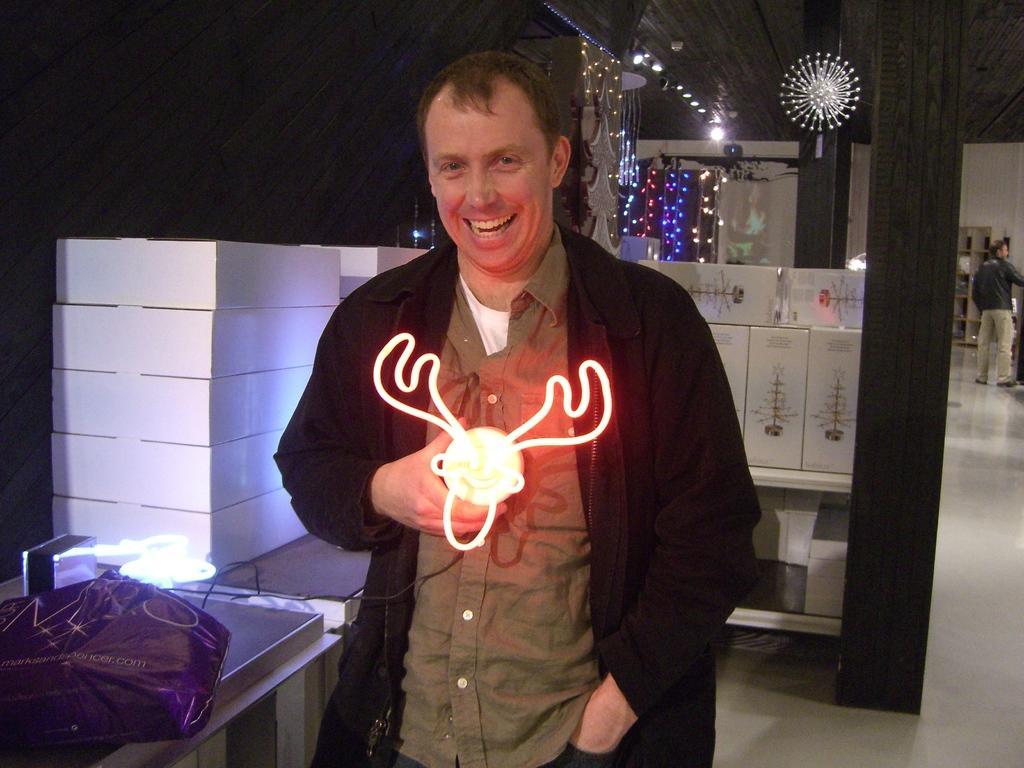Could you give a brief overview of what you see in this image? In this image we can see a person holding an object. Beside the person there are few objects on the table. Behind the person we can see the pillars and few objects on the racks. On the right side of the image we can see a person and a rack. At the top we can see a roof and lights. 